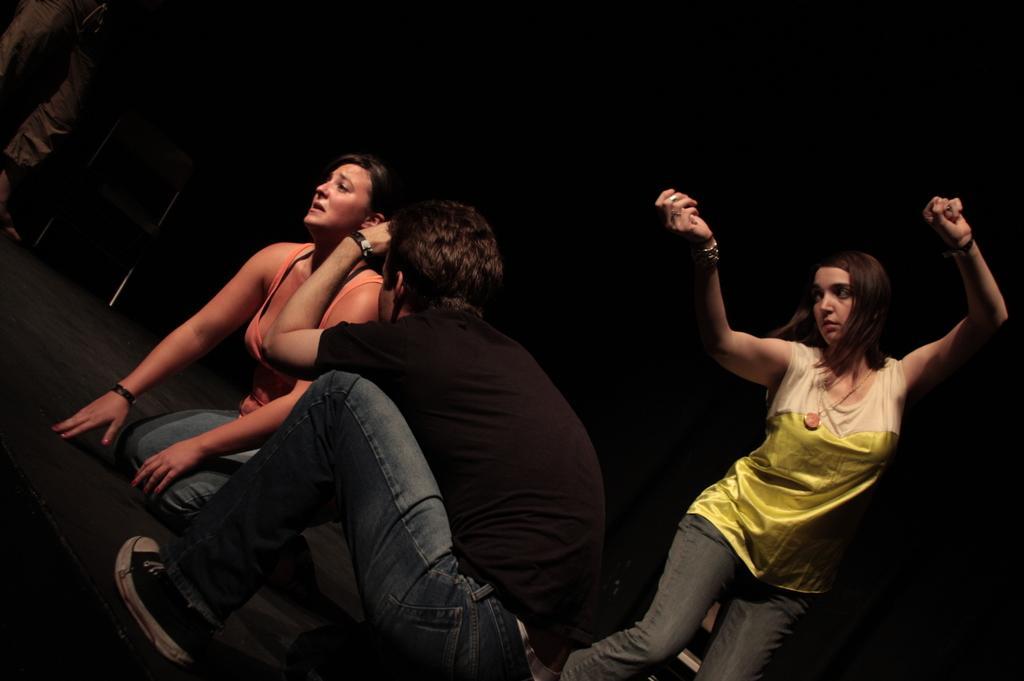Could you give a brief overview of what you see in this image? The picture is taken during a stage performance. In the foreground of the picture there is a person in black t-shirt. On the right there is a woman dancing. In front of the man there is a woman. At the top left there is a person and there is a chair. Background is dark. 